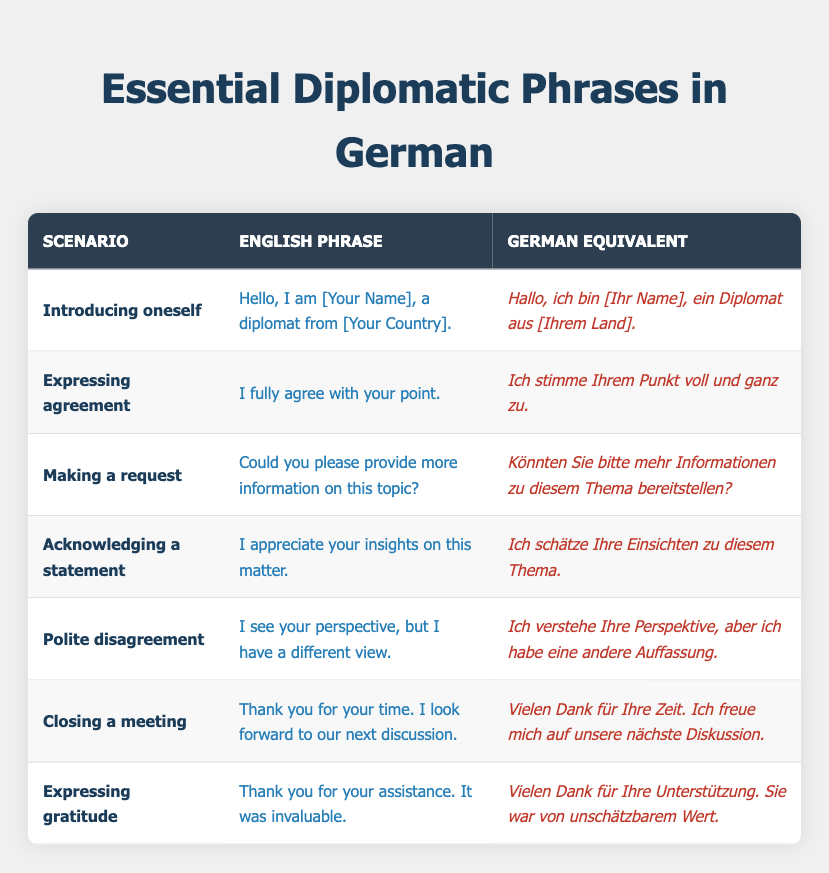What is the German equivalent for expressing gratitude? The phrase for expressing gratitude in German is found in the "Expressing gratitude" scenario, which is "Vielen Dank für Ihre Unterstützung. Sie war von unschätzbarem Wert."
Answer: Vielen Dank für Ihre Unterstützung. Sie war von unschätzbarem Wert How many phrases are related to introducing oneself and closing a meeting? There are two scenarios that are related: "Introducing oneself" and "Closing a meeting." Therefore, the number is 2.
Answer: 2 Is there a phrase for making a request? Yes, there is a phrase for making a request, which is "Könnten Sie bitte mehr Informationen zu diesem Thema bereitstellen?" from the "Making a request" scenario.
Answer: Yes What is the phrase that acknowledges a statement in English? The phrase that acknowledges a statement in English is "I appreciate your insights on this matter." It can be identified in the "Acknowledging a statement" section of the table.
Answer: I appreciate your insights on this matter Which scenario has the German equivalent that starts with "Ich verstehe"? The scenario with the German equivalent that starts with "Ich verstehe" is "Polite disagreement." The complete phrase is "Ich verstehe Ihre Perspektive, aber ich habe eine andere Auffassung."
Answer: Polite disagreement 